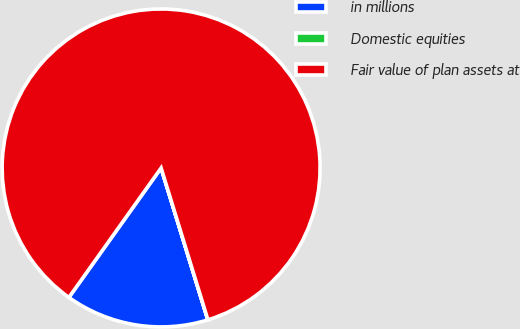<chart> <loc_0><loc_0><loc_500><loc_500><pie_chart><fcel>in millions<fcel>Domestic equities<fcel>Fair value of plan assets at<nl><fcel>14.6%<fcel>0.01%<fcel>85.39%<nl></chart> 